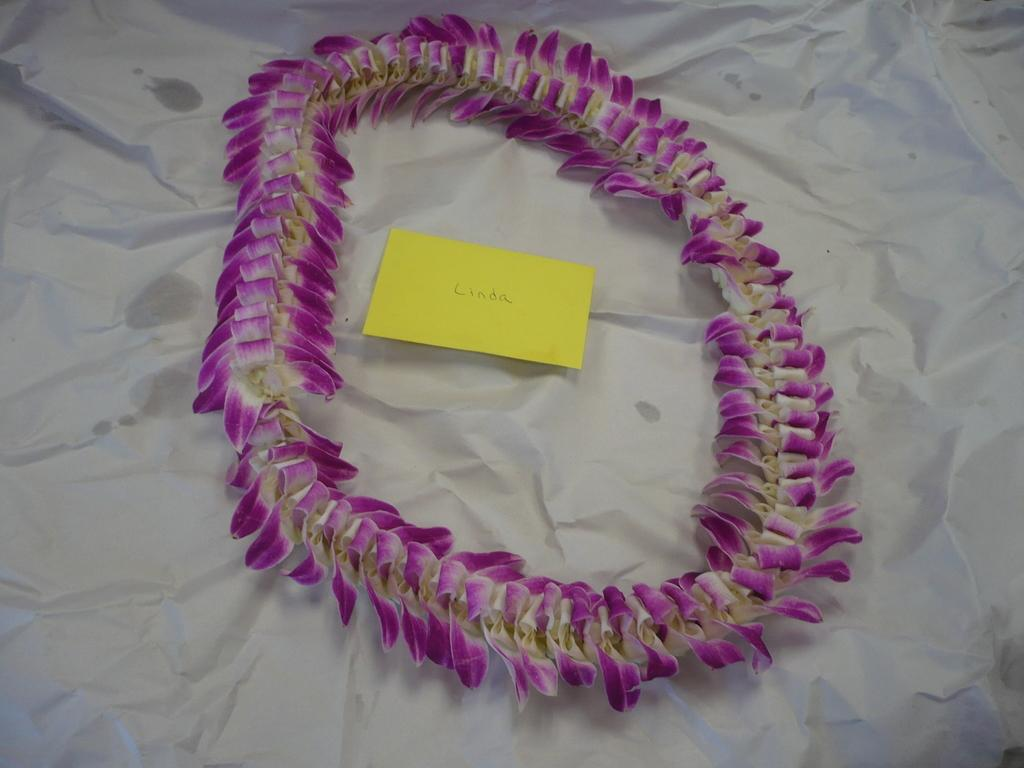What can be seen in the image that is related to decoration? There is a flowers garland in the image. What type of stationery item is present in the image? There is a sticky note on a paper in the image. What type of lace can be seen on the flowers garland in the image? There is no lace present on the flowers garland in the image. Is there any indication of a wound or debt in the image? No, there is no mention or indication of a wound or debt in the image. 